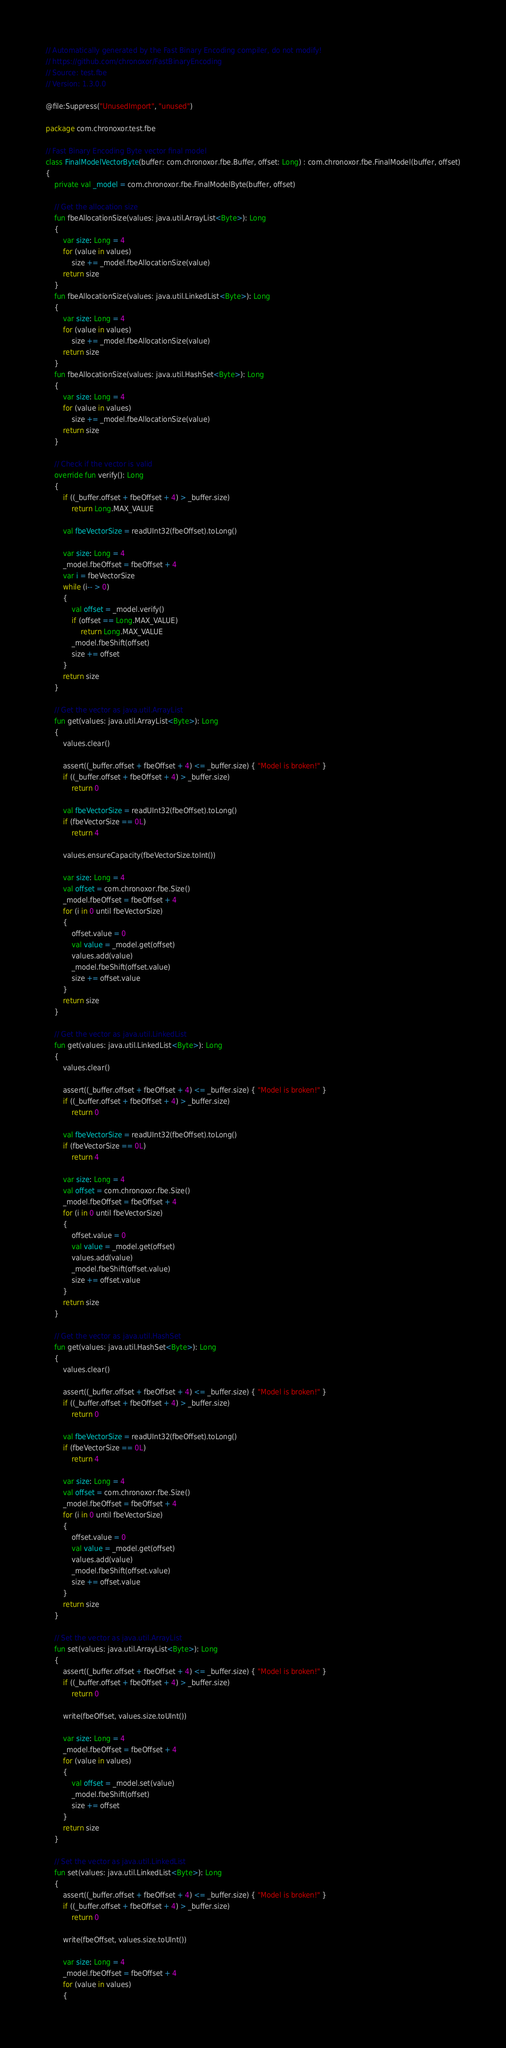<code> <loc_0><loc_0><loc_500><loc_500><_Kotlin_>// Automatically generated by the Fast Binary Encoding compiler, do not modify!
// https://github.com/chronoxor/FastBinaryEncoding
// Source: test.fbe
// Version: 1.3.0.0

@file:Suppress("UnusedImport", "unused")

package com.chronoxor.test.fbe

// Fast Binary Encoding Byte vector final model
class FinalModelVectorByte(buffer: com.chronoxor.fbe.Buffer, offset: Long) : com.chronoxor.fbe.FinalModel(buffer, offset)
{
    private val _model = com.chronoxor.fbe.FinalModelByte(buffer, offset)

    // Get the allocation size
    fun fbeAllocationSize(values: java.util.ArrayList<Byte>): Long
    {
        var size: Long = 4
        for (value in values)
            size += _model.fbeAllocationSize(value)
        return size
    }
    fun fbeAllocationSize(values: java.util.LinkedList<Byte>): Long
    {
        var size: Long = 4
        for (value in values)
            size += _model.fbeAllocationSize(value)
        return size
    }
    fun fbeAllocationSize(values: java.util.HashSet<Byte>): Long
    {
        var size: Long = 4
        for (value in values)
            size += _model.fbeAllocationSize(value)
        return size
    }

    // Check if the vector is valid
    override fun verify(): Long
    {
        if ((_buffer.offset + fbeOffset + 4) > _buffer.size)
            return Long.MAX_VALUE

        val fbeVectorSize = readUInt32(fbeOffset).toLong()

        var size: Long = 4
        _model.fbeOffset = fbeOffset + 4
        var i = fbeVectorSize
        while (i-- > 0)
        {
            val offset = _model.verify()
            if (offset == Long.MAX_VALUE)
                return Long.MAX_VALUE
            _model.fbeShift(offset)
            size += offset
        }
        return size
    }

    // Get the vector as java.util.ArrayList
    fun get(values: java.util.ArrayList<Byte>): Long
    {
        values.clear()

        assert((_buffer.offset + fbeOffset + 4) <= _buffer.size) { "Model is broken!" }
        if ((_buffer.offset + fbeOffset + 4) > _buffer.size)
            return 0

        val fbeVectorSize = readUInt32(fbeOffset).toLong()
        if (fbeVectorSize == 0L)
            return 4

        values.ensureCapacity(fbeVectorSize.toInt())

        var size: Long = 4
        val offset = com.chronoxor.fbe.Size()
        _model.fbeOffset = fbeOffset + 4
        for (i in 0 until fbeVectorSize)
        {
            offset.value = 0
            val value = _model.get(offset)
            values.add(value)
            _model.fbeShift(offset.value)
            size += offset.value
        }
        return size
    }

    // Get the vector as java.util.LinkedList
    fun get(values: java.util.LinkedList<Byte>): Long
    {
        values.clear()

        assert((_buffer.offset + fbeOffset + 4) <= _buffer.size) { "Model is broken!" }
        if ((_buffer.offset + fbeOffset + 4) > _buffer.size)
            return 0

        val fbeVectorSize = readUInt32(fbeOffset).toLong()
        if (fbeVectorSize == 0L)
            return 4

        var size: Long = 4
        val offset = com.chronoxor.fbe.Size()
        _model.fbeOffset = fbeOffset + 4
        for (i in 0 until fbeVectorSize)
        {
            offset.value = 0
            val value = _model.get(offset)
            values.add(value)
            _model.fbeShift(offset.value)
            size += offset.value
        }
        return size
    }

    // Get the vector as java.util.HashSet
    fun get(values: java.util.HashSet<Byte>): Long
    {
        values.clear()

        assert((_buffer.offset + fbeOffset + 4) <= _buffer.size) { "Model is broken!" }
        if ((_buffer.offset + fbeOffset + 4) > _buffer.size)
            return 0

        val fbeVectorSize = readUInt32(fbeOffset).toLong()
        if (fbeVectorSize == 0L)
            return 4

        var size: Long = 4
        val offset = com.chronoxor.fbe.Size()
        _model.fbeOffset = fbeOffset + 4
        for (i in 0 until fbeVectorSize)
        {
            offset.value = 0
            val value = _model.get(offset)
            values.add(value)
            _model.fbeShift(offset.value)
            size += offset.value
        }
        return size
    }

    // Set the vector as java.util.ArrayList
    fun set(values: java.util.ArrayList<Byte>): Long
    {
        assert((_buffer.offset + fbeOffset + 4) <= _buffer.size) { "Model is broken!" }
        if ((_buffer.offset + fbeOffset + 4) > _buffer.size)
            return 0

        write(fbeOffset, values.size.toUInt())

        var size: Long = 4
        _model.fbeOffset = fbeOffset + 4
        for (value in values)
        {
            val offset = _model.set(value)
            _model.fbeShift(offset)
            size += offset
        }
        return size
    }

    // Set the vector as java.util.LinkedList
    fun set(values: java.util.LinkedList<Byte>): Long
    {
        assert((_buffer.offset + fbeOffset + 4) <= _buffer.size) { "Model is broken!" }
        if ((_buffer.offset + fbeOffset + 4) > _buffer.size)
            return 0

        write(fbeOffset, values.size.toUInt())

        var size: Long = 4
        _model.fbeOffset = fbeOffset + 4
        for (value in values)
        {</code> 